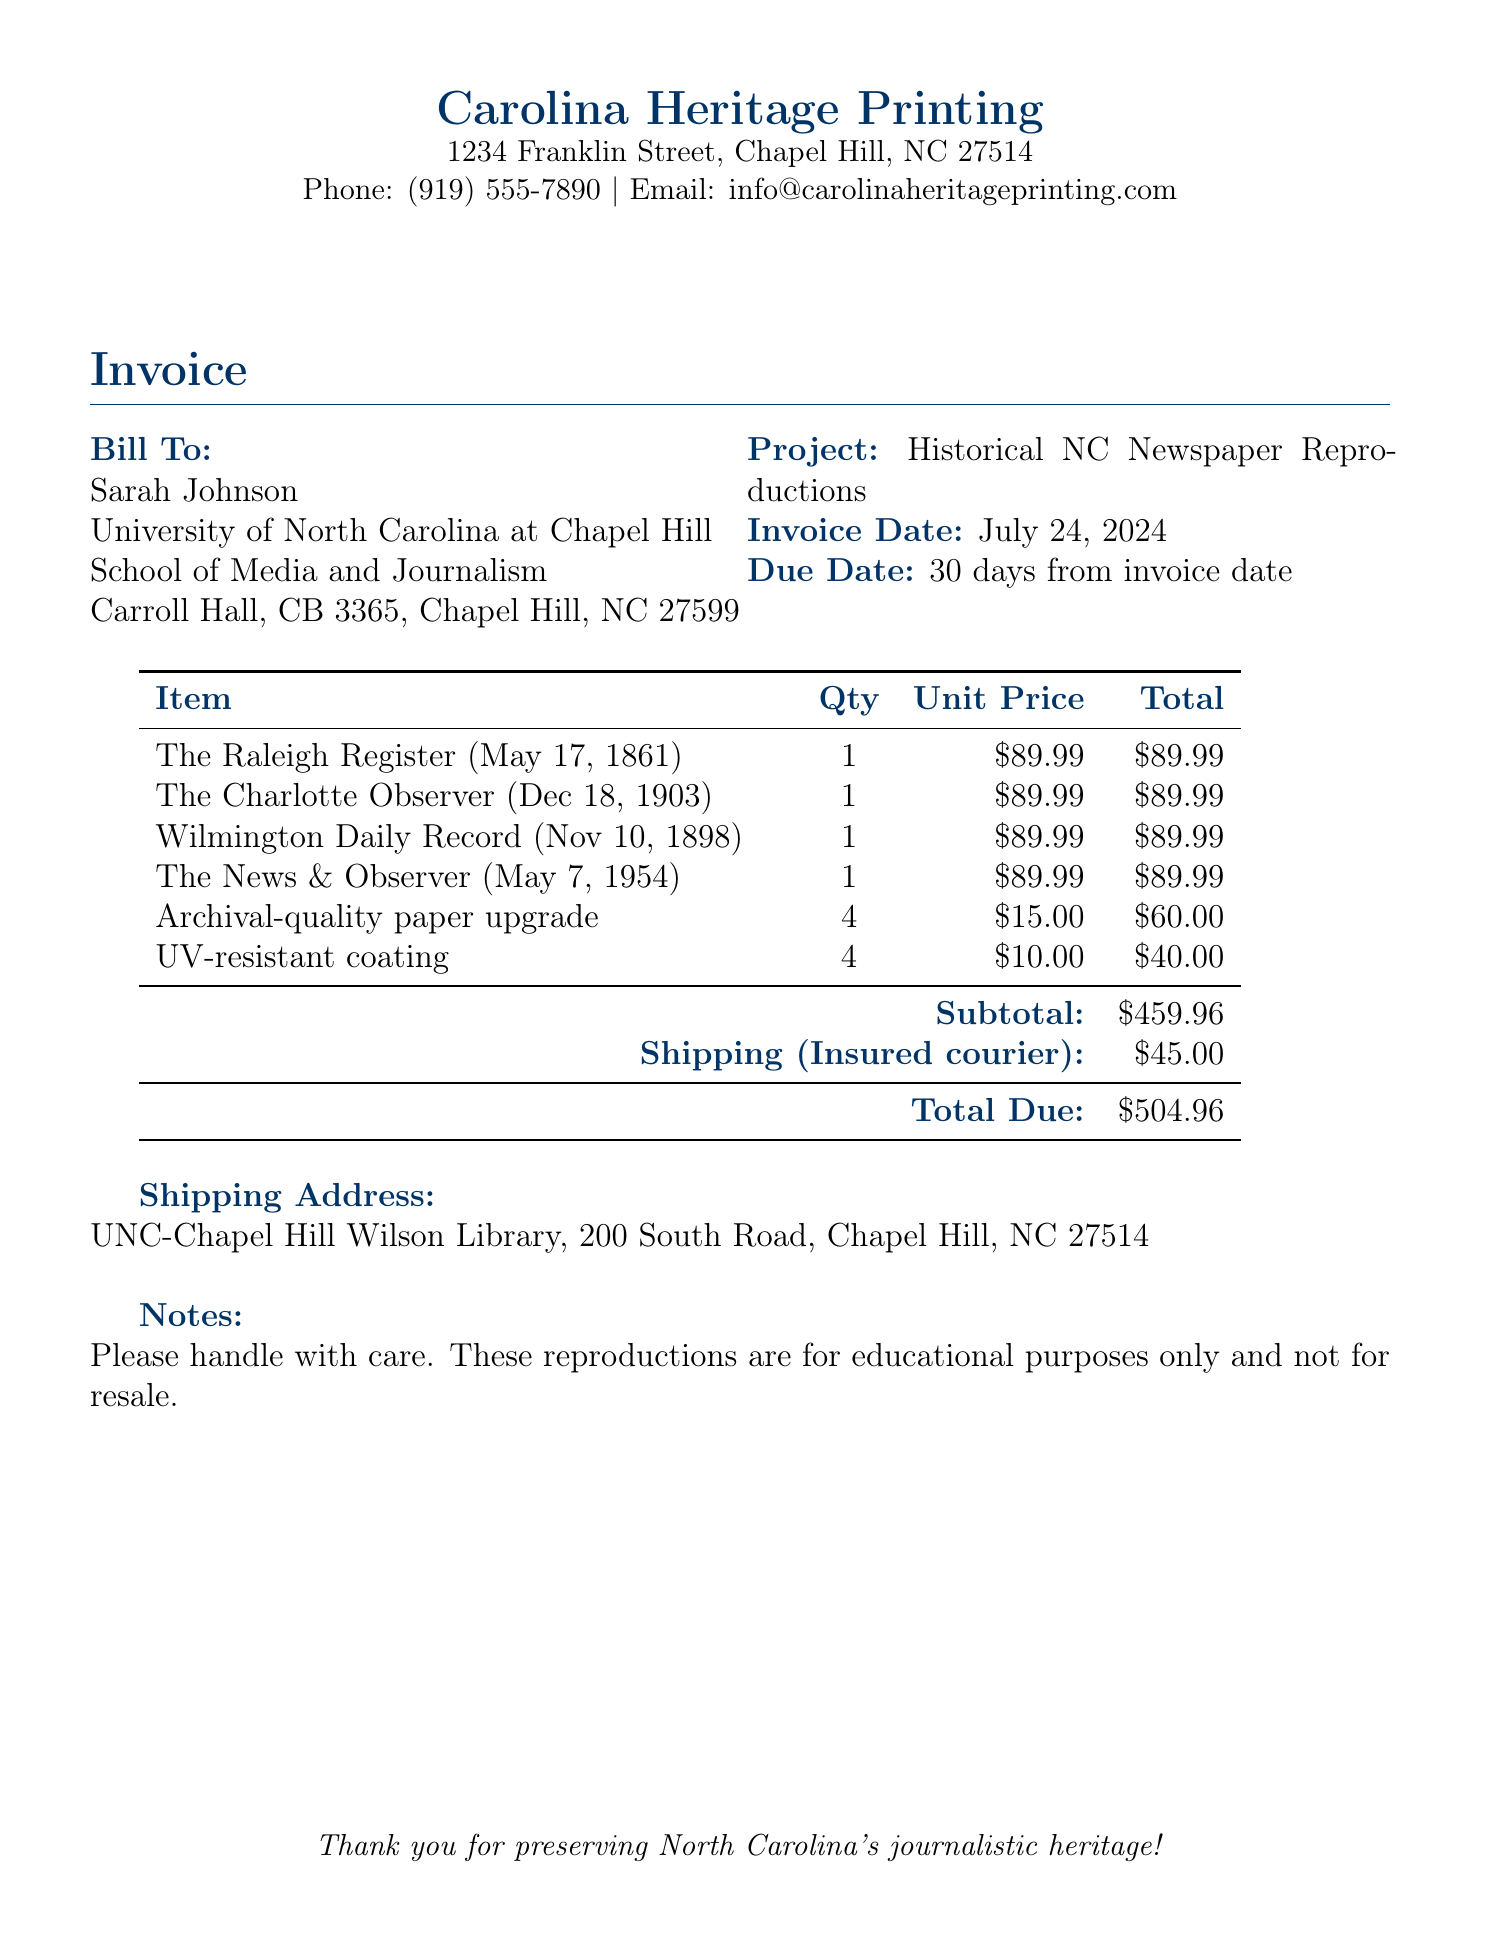What is the invoice date? The invoice date is listed in the document under "Invoice Date," which is the current date when the bill was issued.
Answer: today Who is the bill addressed to? The bill is addressed to the individual listed under "Bill To," which identifies the recipient as Sarah Johnson.
Answer: Sarah Johnson What is the total due amount? The total due is specified at the end of the invoice, which sums up all costs including shipping.
Answer: $504.96 How many copies of "The Raleigh Register" are being ordered? The quantity for "The Raleigh Register" is provided in the item list, indicating how many copies are being produced.
Answer: 1 What is the unit price for the "Wilmington Daily Record"? The unit price for the "Wilmington Daily Record" is mentioned specifically alongside the item description.
Answer: $89.99 What type of paper upgrade is included in the invoice? The document mentions a specific enhancement for prints listed under the itemized charges.
Answer: Archival-quality paper upgrade What is the subtotal amount before shipping? The subtotal is calculated by adding up all item costs provided in the invoice before shipping is added.
Answer: $459.96 How much is charged for shipping? The shipping cost is explicitly stated in the invoice under the shipping section, indicating how much is being charged for delivery.
Answer: $45.00 What is the shipping address for the order? The shipping address is located in the section marked "Shipping Address," detailing where the items will be sent.
Answer: UNC-Chapel Hill Wilson Library, 200 South Road, Chapel Hill, NC 27514 